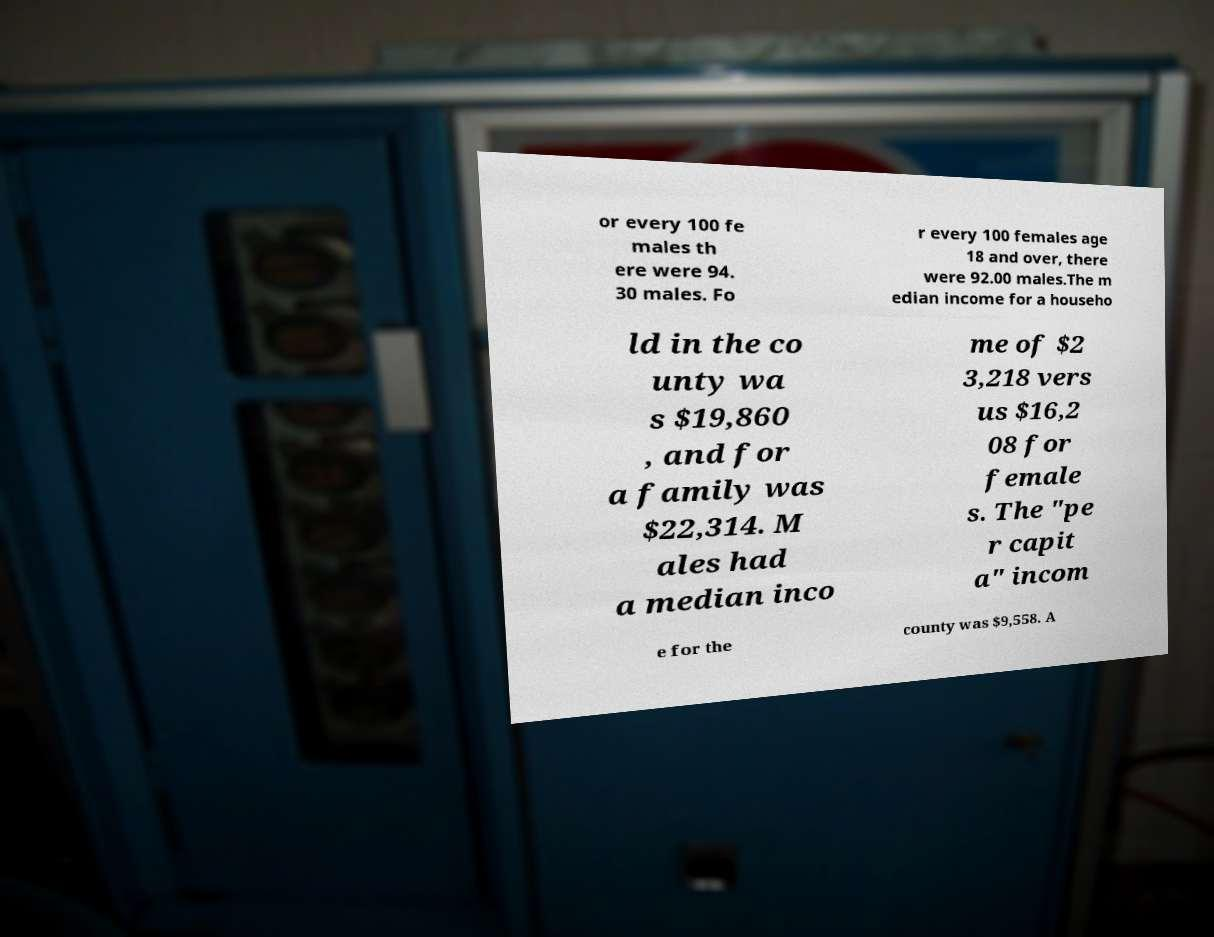I need the written content from this picture converted into text. Can you do that? or every 100 fe males th ere were 94. 30 males. Fo r every 100 females age 18 and over, there were 92.00 males.The m edian income for a househo ld in the co unty wa s $19,860 , and for a family was $22,314. M ales had a median inco me of $2 3,218 vers us $16,2 08 for female s. The "pe r capit a" incom e for the county was $9,558. A 